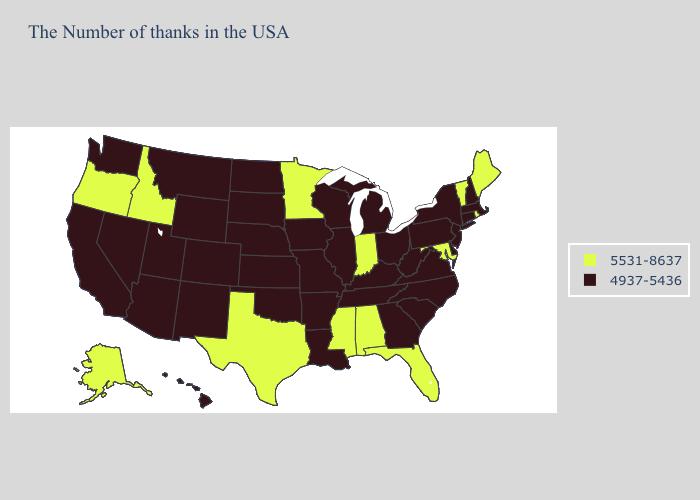Among the states that border New Mexico , which have the highest value?
Keep it brief. Texas. Does the first symbol in the legend represent the smallest category?
Short answer required. No. Name the states that have a value in the range 5531-8637?
Concise answer only. Maine, Rhode Island, Vermont, Maryland, Florida, Indiana, Alabama, Mississippi, Minnesota, Texas, Idaho, Oregon, Alaska. Name the states that have a value in the range 5531-8637?
Answer briefly. Maine, Rhode Island, Vermont, Maryland, Florida, Indiana, Alabama, Mississippi, Minnesota, Texas, Idaho, Oregon, Alaska. Which states have the lowest value in the USA?
Write a very short answer. Massachusetts, New Hampshire, Connecticut, New York, New Jersey, Delaware, Pennsylvania, Virginia, North Carolina, South Carolina, West Virginia, Ohio, Georgia, Michigan, Kentucky, Tennessee, Wisconsin, Illinois, Louisiana, Missouri, Arkansas, Iowa, Kansas, Nebraska, Oklahoma, South Dakota, North Dakota, Wyoming, Colorado, New Mexico, Utah, Montana, Arizona, Nevada, California, Washington, Hawaii. How many symbols are there in the legend?
Quick response, please. 2. Which states have the lowest value in the MidWest?
Be succinct. Ohio, Michigan, Wisconsin, Illinois, Missouri, Iowa, Kansas, Nebraska, South Dakota, North Dakota. What is the value of California?
Answer briefly. 4937-5436. Does Hawaii have the highest value in the USA?
Give a very brief answer. No. What is the value of Washington?
Give a very brief answer. 4937-5436. Among the states that border Illinois , does Indiana have the lowest value?
Short answer required. No. Which states have the lowest value in the MidWest?
Quick response, please. Ohio, Michigan, Wisconsin, Illinois, Missouri, Iowa, Kansas, Nebraska, South Dakota, North Dakota. Does Alaska have the highest value in the West?
Give a very brief answer. Yes. Name the states that have a value in the range 5531-8637?
Write a very short answer. Maine, Rhode Island, Vermont, Maryland, Florida, Indiana, Alabama, Mississippi, Minnesota, Texas, Idaho, Oregon, Alaska. Does the first symbol in the legend represent the smallest category?
Give a very brief answer. No. 